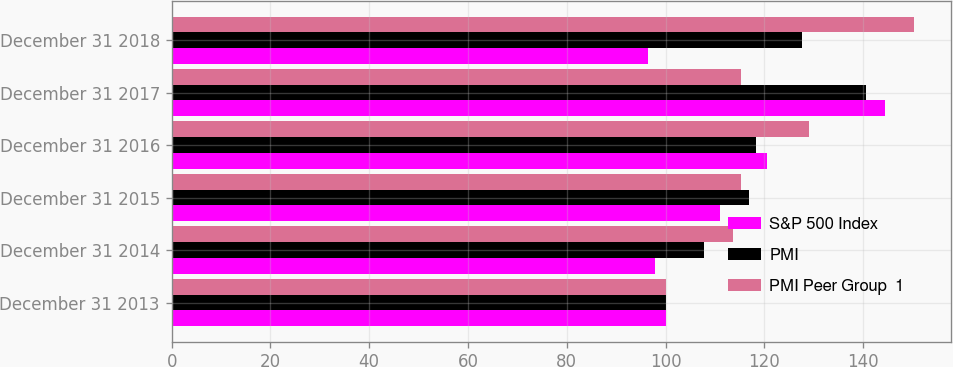Convert chart. <chart><loc_0><loc_0><loc_500><loc_500><stacked_bar_chart><ecel><fcel>December 31 2013<fcel>December 31 2014<fcel>December 31 2015<fcel>December 31 2016<fcel>December 31 2017<fcel>December 31 2018<nl><fcel>S&P 500 Index<fcel>100<fcel>97.9<fcel>111<fcel>120.5<fcel>144.5<fcel>96.5<nl><fcel>PMI<fcel>100<fcel>107.8<fcel>116.8<fcel>118.4<fcel>140.5<fcel>127.7<nl><fcel>PMI Peer Group  1<fcel>100<fcel>113.7<fcel>115.3<fcel>129<fcel>115.3<fcel>150.3<nl></chart> 